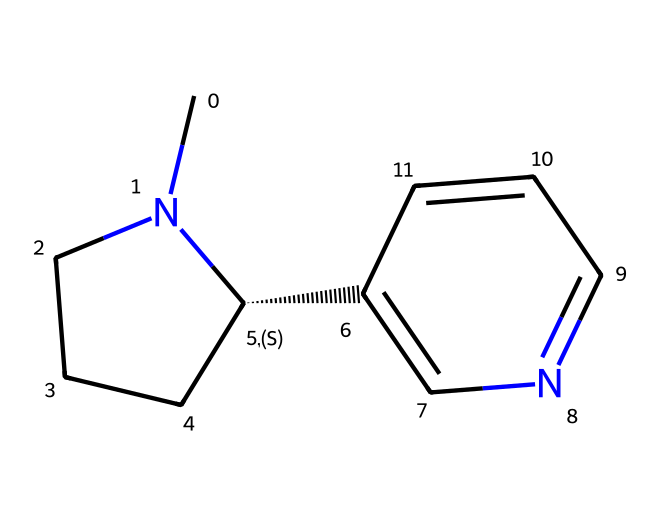What is the molecular formula of this chemical? To determine the molecular formula, we count the number of each type of atom present in the chemical structure given by the SMILES representation. There are 10 carbons (C), 14 hydrogens (H), and 2 nitrogens (N), giving us the formula C10H14N2.
Answer: C10H14N2 How many nitrogen atoms are present in this compound? By examining the SMILES, we identify the nitrogen atoms represented by 'N.' There are 2 nitrogen atoms in the structure.
Answer: 2 Is this chemical an alkaloid? The presence of nitrogen atoms in a heterocyclic compound typically indicates that it is an alkaloid. Since this structure contains nitrogen and is derived from tobacco, it is classified as an alkaloid.
Answer: Yes What type of functional groups are present in this chemical? Analyzing the structure indicates that it contains a pyridine ring (due to its nitrogen and cyclic structure) and a piperidine ring (due to the saturated nitrogen). These are typical in alkaloids, resulting in multi-ring systems.
Answer: Pyridine and piperidine What is the significance of nicotine in smoking cessation products? Nicotine is the active component found in nicotine replacement therapies, which help reduce withdrawal symptoms and cravings in individuals trying to quit smoking.
Answer: Active component What is the stereochemistry of this chemical? Examining the SMILES representation, we identify the '@' symbol denoting a chiral center. Thus, the stereochemistry indicates that this compound has a specific spatial arrangement, exhibiting chirality, particularly at the chiral carbon.
Answer: Chiral How does the presence of nitrogen affect the behavior of this compound in the body? Nitrogen atoms are known to form hydrogen bonds and interact with various receptors, particularly nicotinic acetylcholine receptors, leading to the stimulation of neurotransmitter release in the nervous system. This is a key aspect of nicotine's effects in the body.
Answer: Stimulation of receptors 